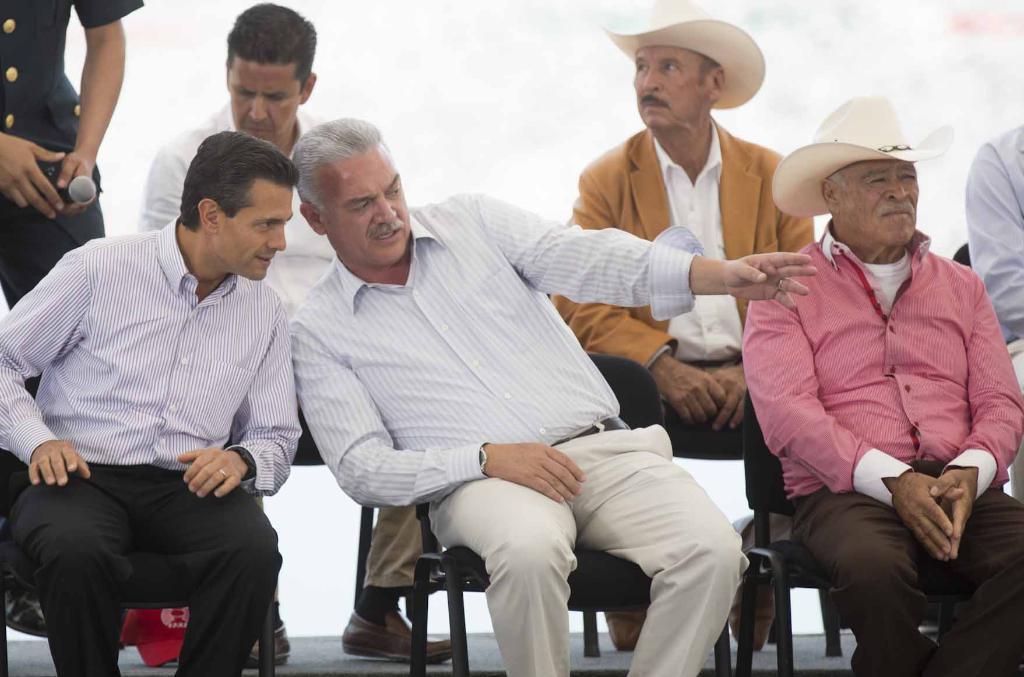How would you summarize this image in a sentence or two? In the image there are group of people sitting on the chair and in the front two men are discussing something with each other and behind them a person is standing and holding a mic in his hand. 